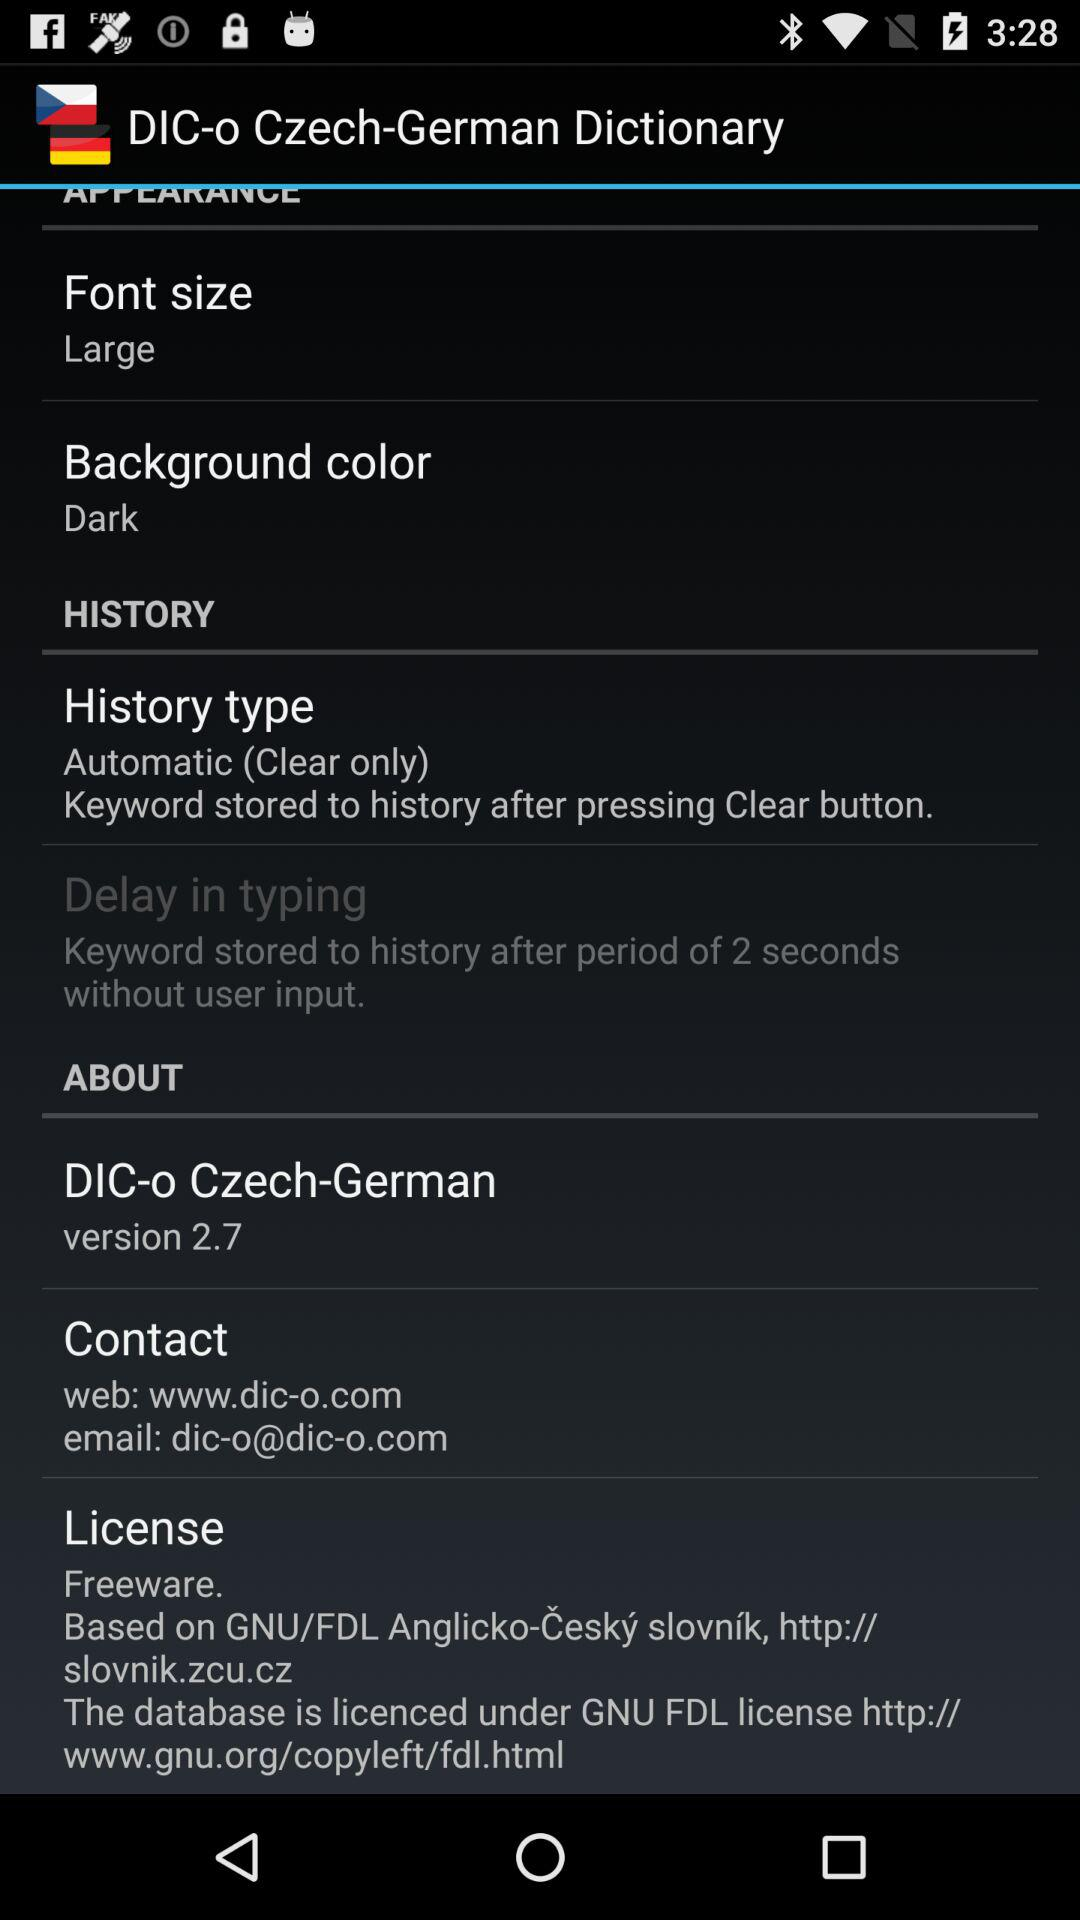What is the email address? The email address is dic-o@dic-o.com. 